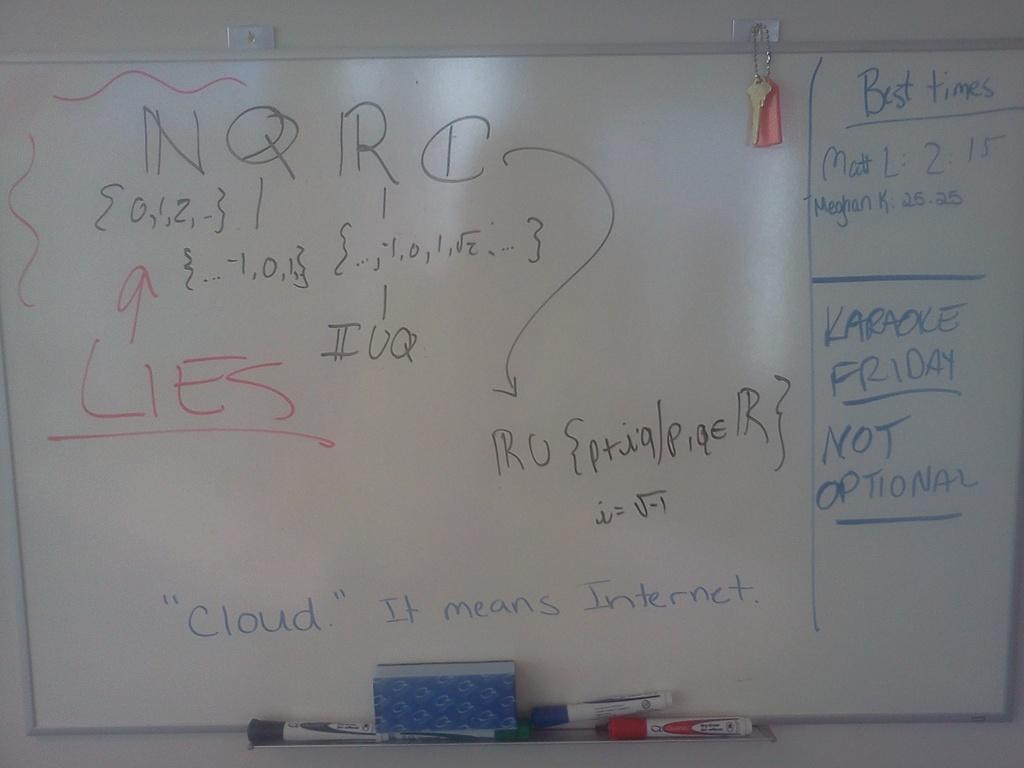<image>
Present a compact description of the photo's key features. The word "LIES" is underlined and colored in red on the whiteboard. 